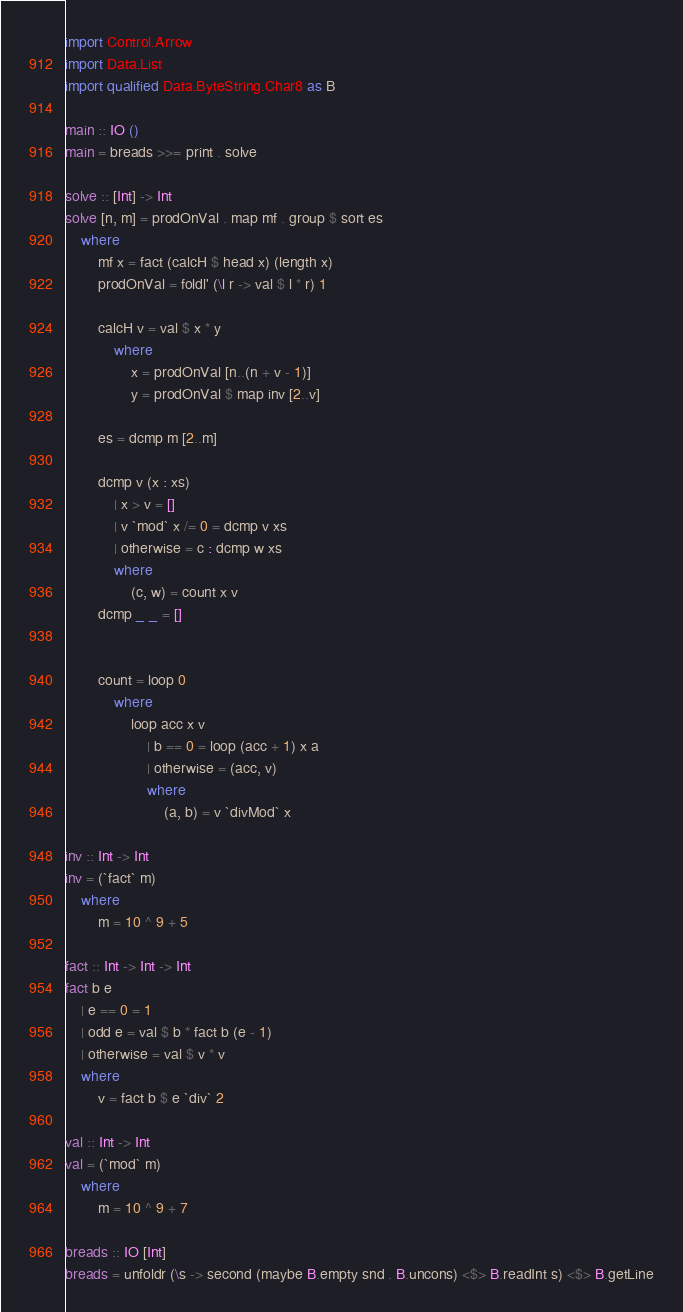Convert code to text. <code><loc_0><loc_0><loc_500><loc_500><_Haskell_>import Control.Arrow
import Data.List
import qualified Data.ByteString.Char8 as B

main :: IO ()
main = breads >>= print . solve 

solve :: [Int] -> Int
solve [n, m] = prodOnVal . map mf . group $ sort es
    where
        mf x = fact (calcH $ head x) (length x)
        prodOnVal = foldl' (\l r -> val $ l * r) 1

        calcH v = val $ x * y
            where
                x = prodOnVal [n..(n + v - 1)]
                y = prodOnVal $ map inv [2..v]

        es = dcmp m [2..m]
        
        dcmp v (x : xs)
            | x > v = []
            | v `mod` x /= 0 = dcmp v xs
            | otherwise = c : dcmp w xs
            where
                (c, w) = count x v
        dcmp _ _ = []

        
        count = loop 0
            where
                loop acc x v
                    | b == 0 = loop (acc + 1) x a
                    | otherwise = (acc, v)
                    where
                        (a, b) = v `divMod` x

inv :: Int -> Int 
inv = (`fact` m)
    where
        m = 10 ^ 9 + 5

fact :: Int -> Int -> Int
fact b e
    | e == 0 = 1
    | odd e = val $ b * fact b (e - 1)
    | otherwise = val $ v * v
    where
        v = fact b $ e `div` 2

val :: Int -> Int 
val = (`mod` m)
    where
        m = 10 ^ 9 + 7

breads :: IO [Int]
breads = unfoldr (\s -> second (maybe B.empty snd . B.uncons) <$> B.readInt s) <$> B.getLine</code> 